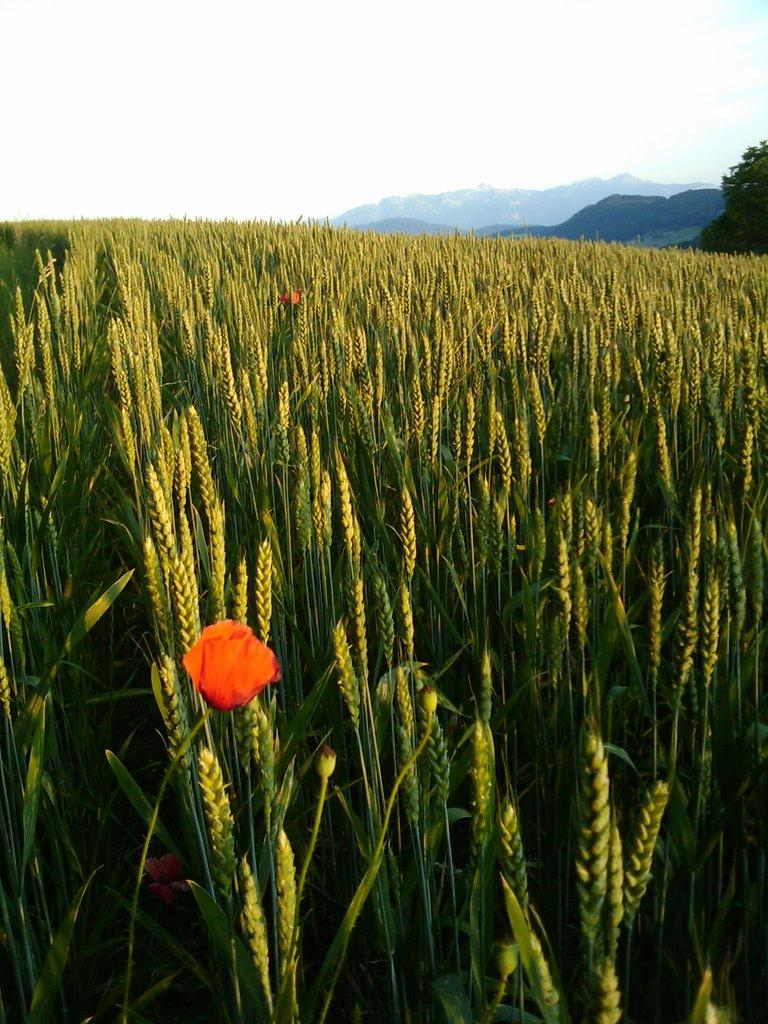What type of living organisms can be seen in the image? Plants and a flower are visible in the image. What is the color of the flower in the image? The flower in the image is orange in color. What can be seen in the background of the image? Mountains, trees, and the sky are visible in the background of the image. What is the manager's degree in the image? There is no manager or degree mentioned or depicted in the image. What type of crack is visible on the flower in the image? There is no crack visible on the flower in the image; it appears to be intact and undamaged. 